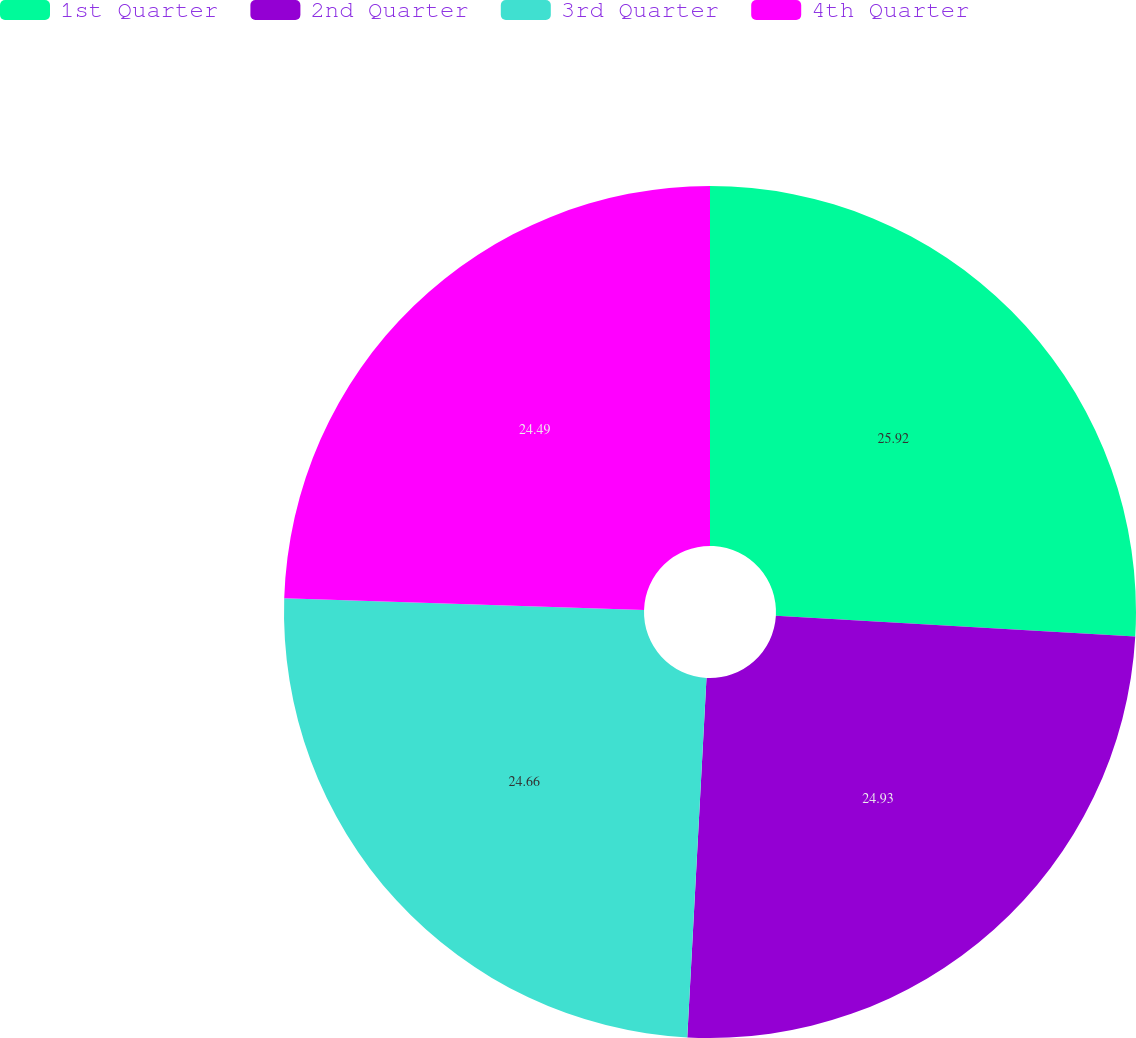Convert chart to OTSL. <chart><loc_0><loc_0><loc_500><loc_500><pie_chart><fcel>1st Quarter<fcel>2nd Quarter<fcel>3rd Quarter<fcel>4th Quarter<nl><fcel>25.92%<fcel>24.93%<fcel>24.66%<fcel>24.49%<nl></chart> 